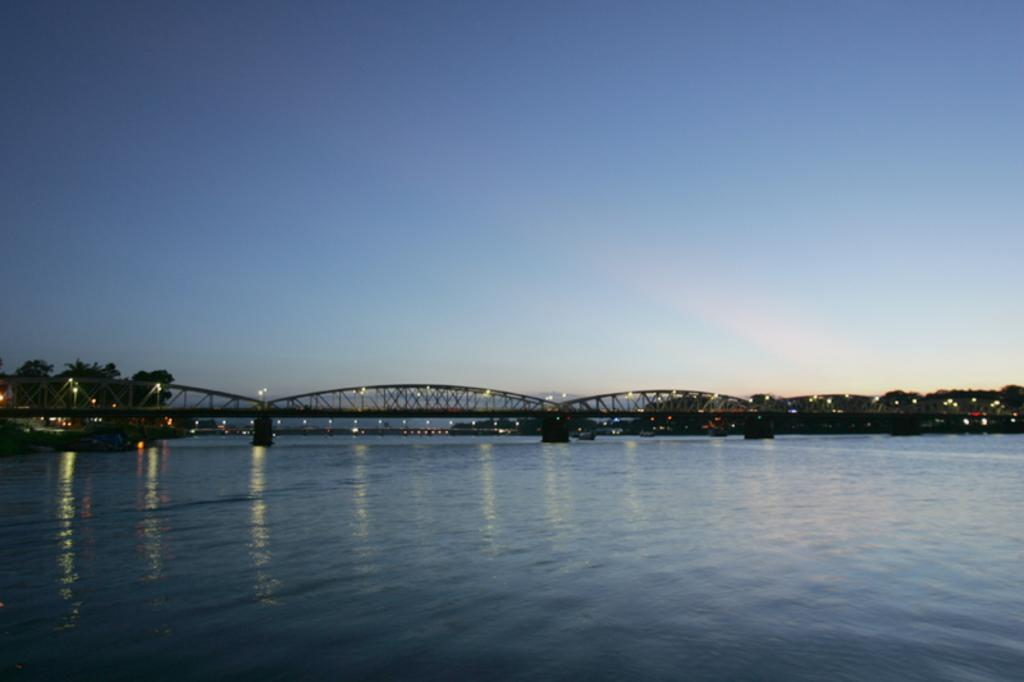What structure is present in the image? There is a bridge in the image. What can be seen at the bottom of the image? There is water at the bottom of the image. What type of vegetation is visible in the background of the image? There are trees in the background of the image. What else can be seen in the background of the image? There are lights in the background of the image. What is visible at the top of the image? The sky is visible at the top of the image. What type of picture is visible on the page in the image? There is no page or picture present in the image; it features a bridge, water, trees, lights, and the sky. 